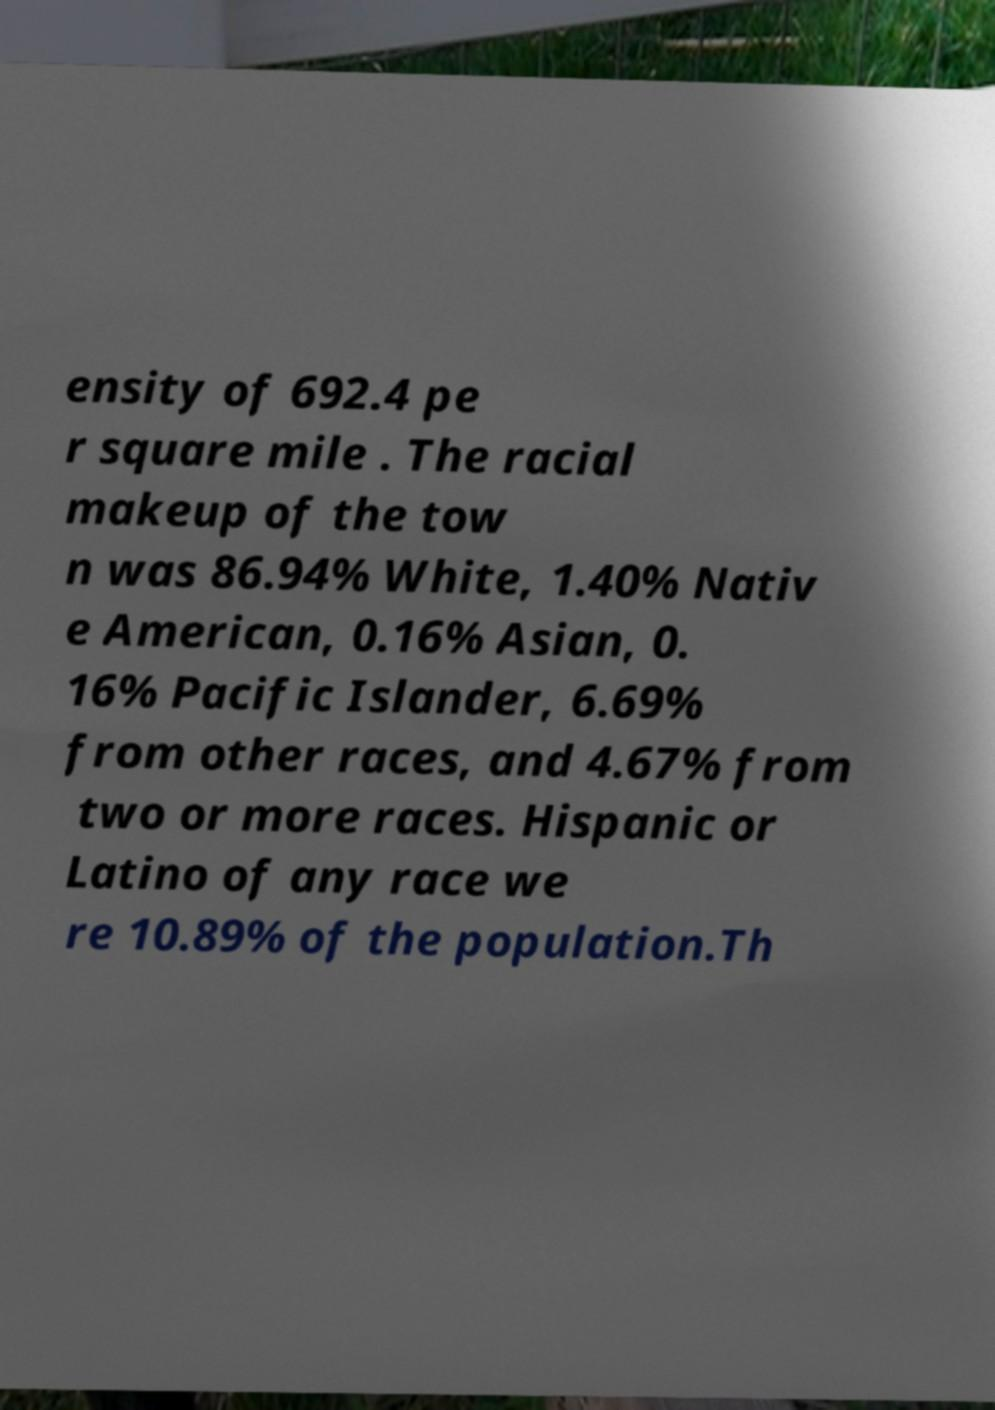I need the written content from this picture converted into text. Can you do that? ensity of 692.4 pe r square mile . The racial makeup of the tow n was 86.94% White, 1.40% Nativ e American, 0.16% Asian, 0. 16% Pacific Islander, 6.69% from other races, and 4.67% from two or more races. Hispanic or Latino of any race we re 10.89% of the population.Th 